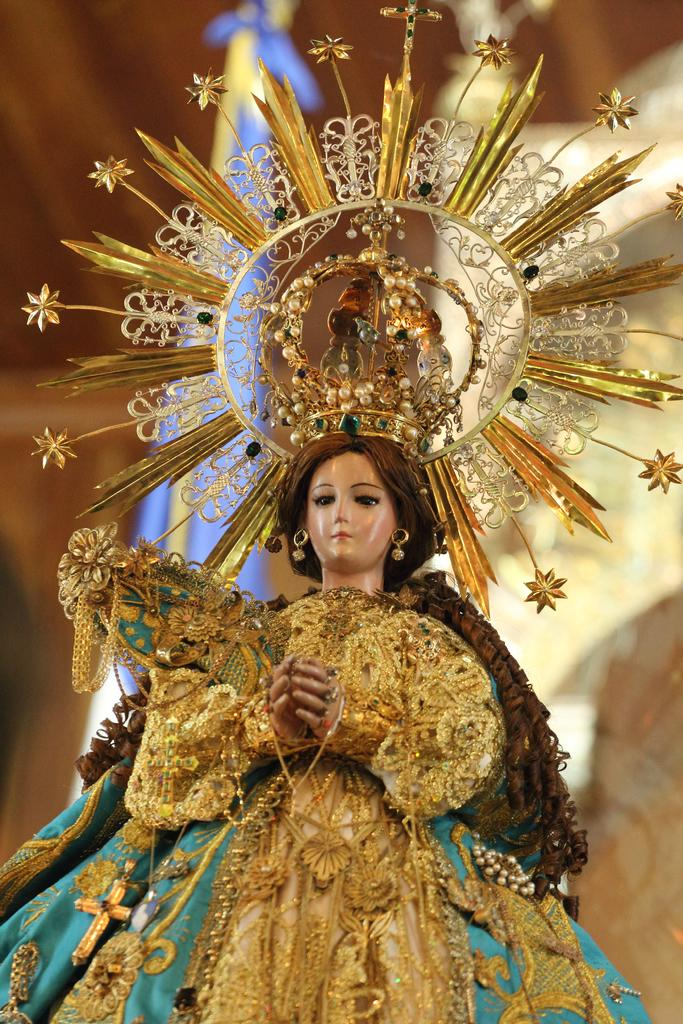What is the main subject in the foreground of the picture? There is a sculpture in the foreground of the picture. What is a notable feature of the sculpture? The sculpture has a crown on it. Can you describe the background of the image? The background of the image is blurred. What type of quiver is the sculpture holding in the image? There is no quiver present in the image; the sculpture has a crown on it. 